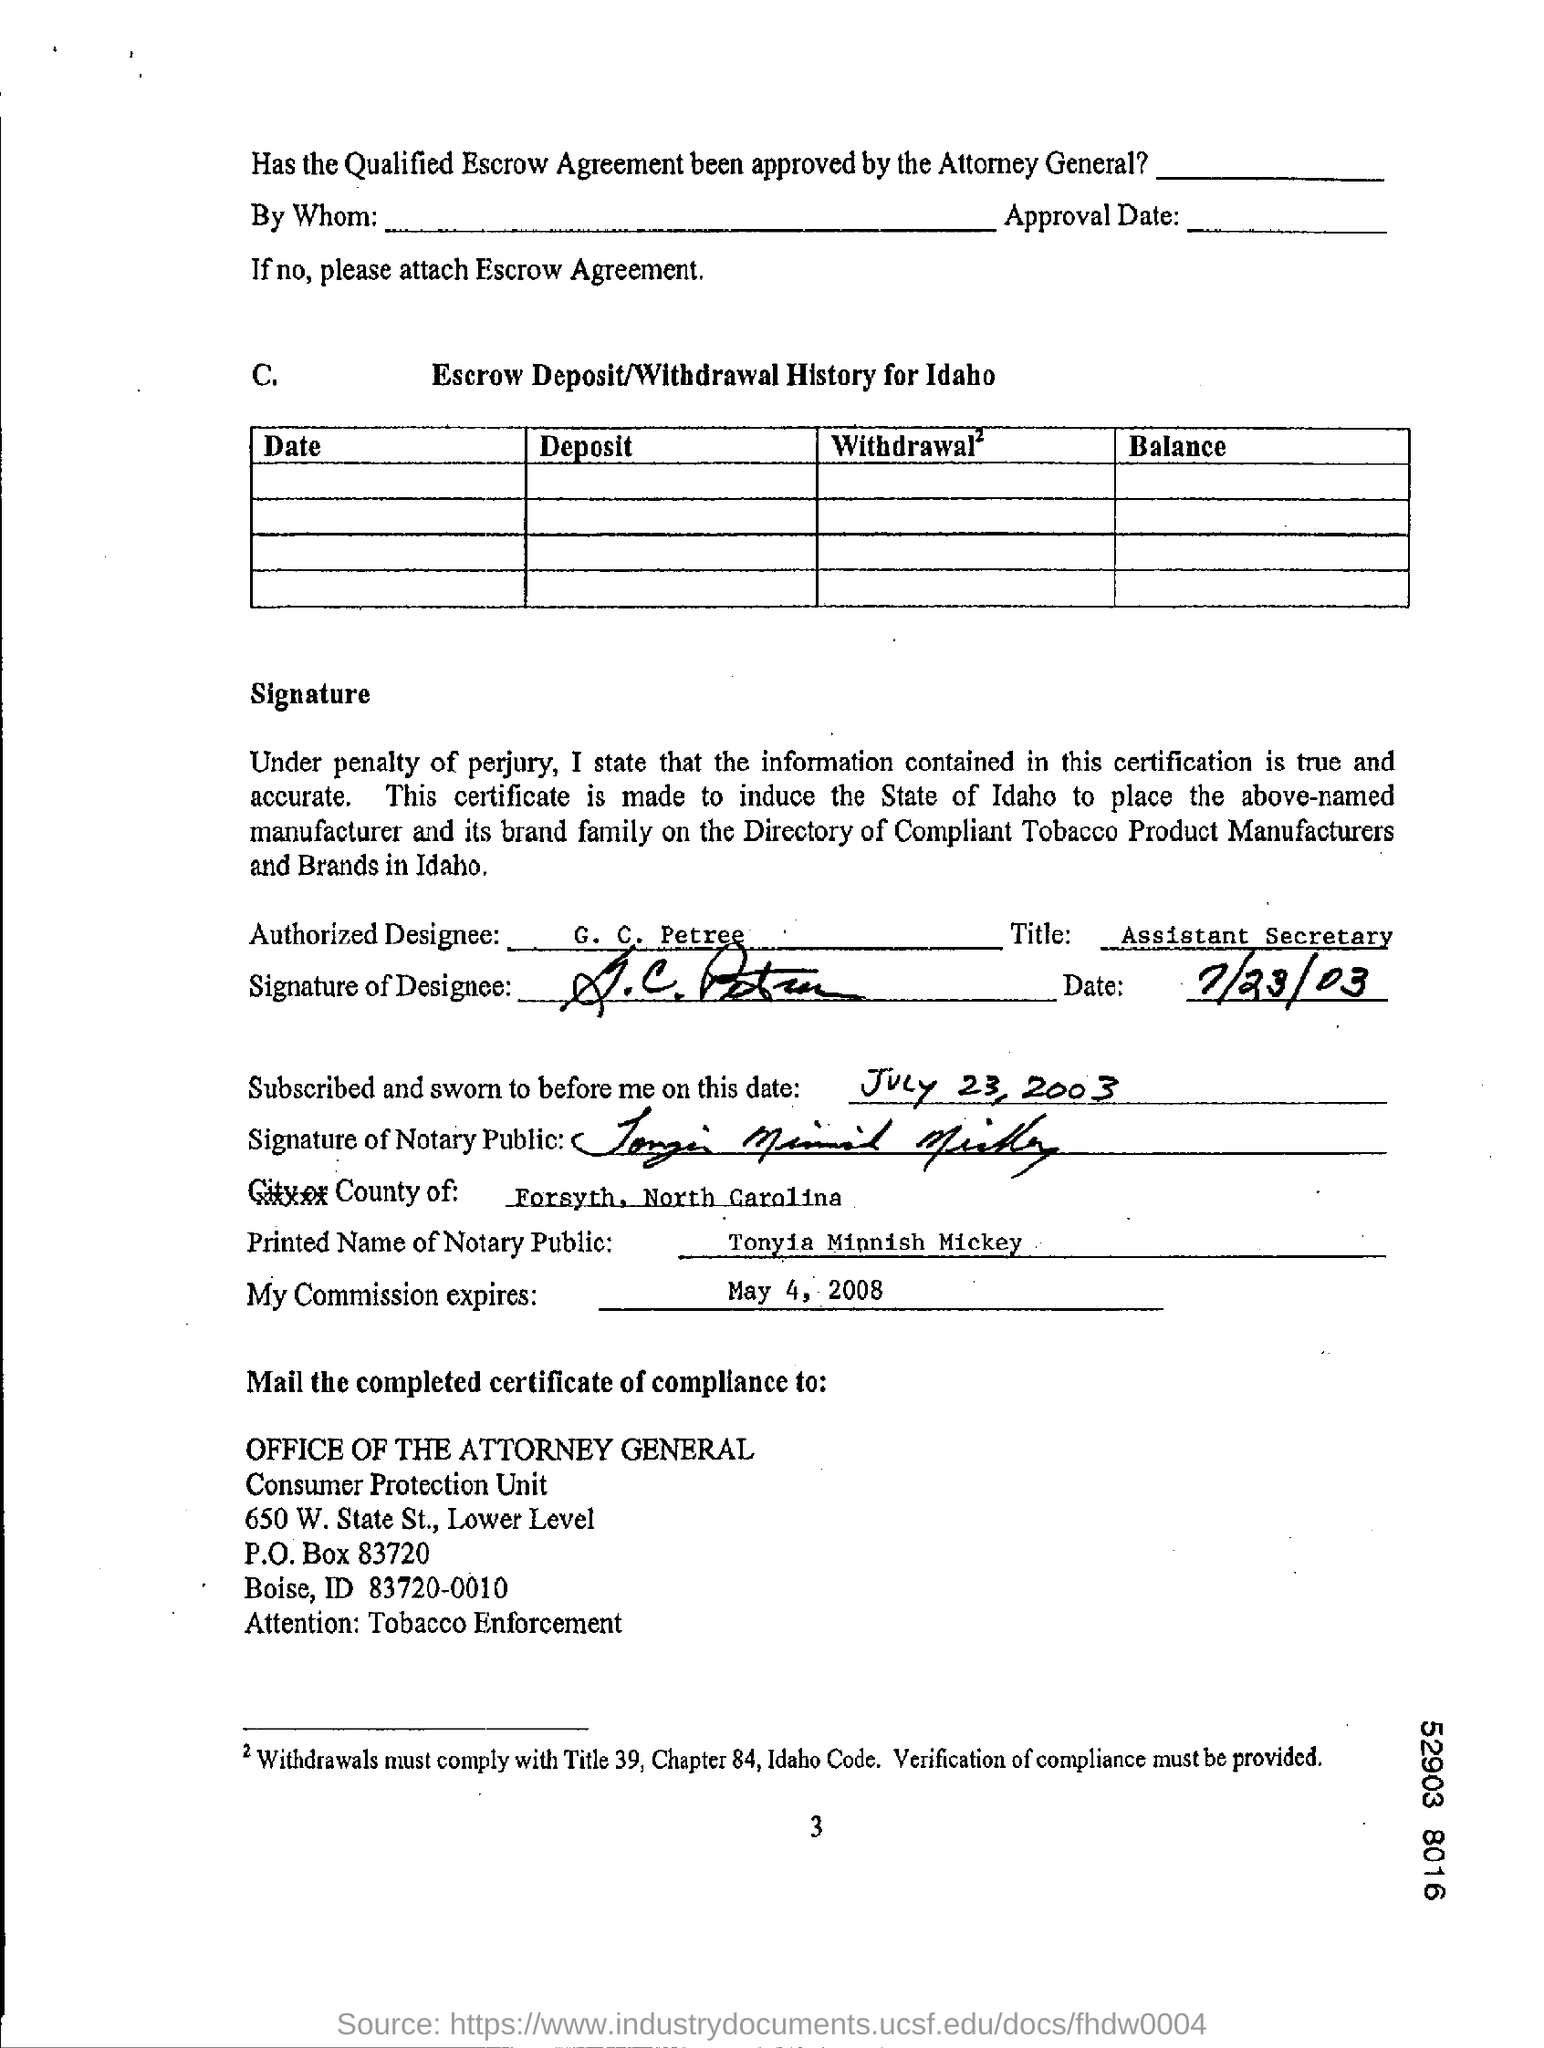List a handful of essential elements in this visual. G.C. Petree is the Assistant Secretary. The authorized designee is G. C. Petree. 